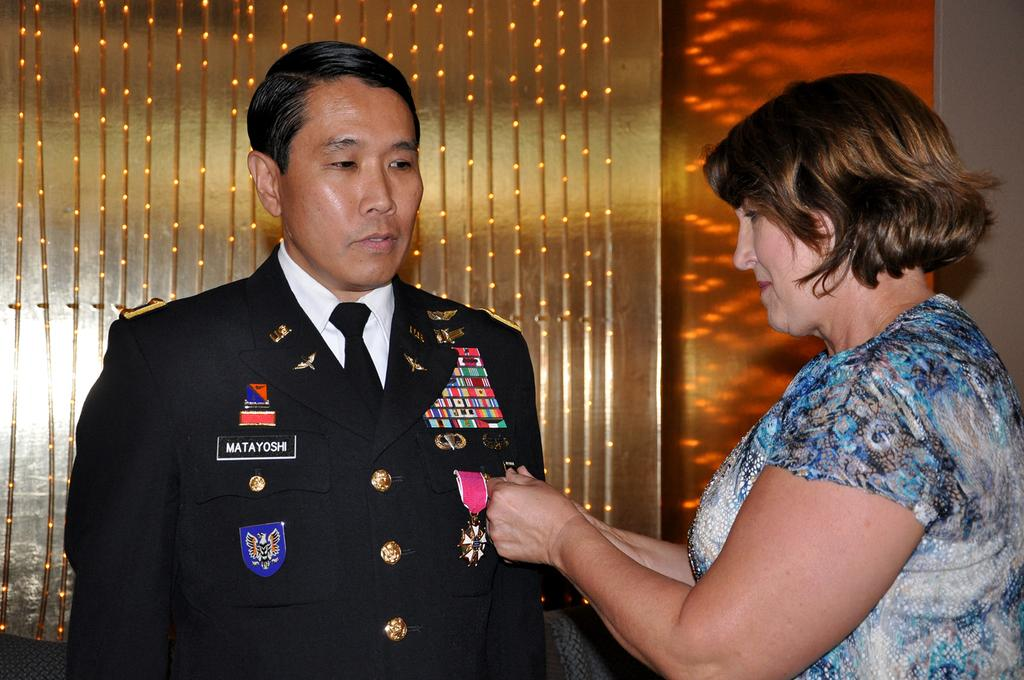How many people are in the image? There are two persons in the image. What is located behind the people in the image? The wall is located behind the people in the image. What can be seen attached to the wall in the image? Objects such as lights are attached to the wall in the image. What type of magic is being performed by the persons in the image? There is no indication of magic or any magical activity in the image. 